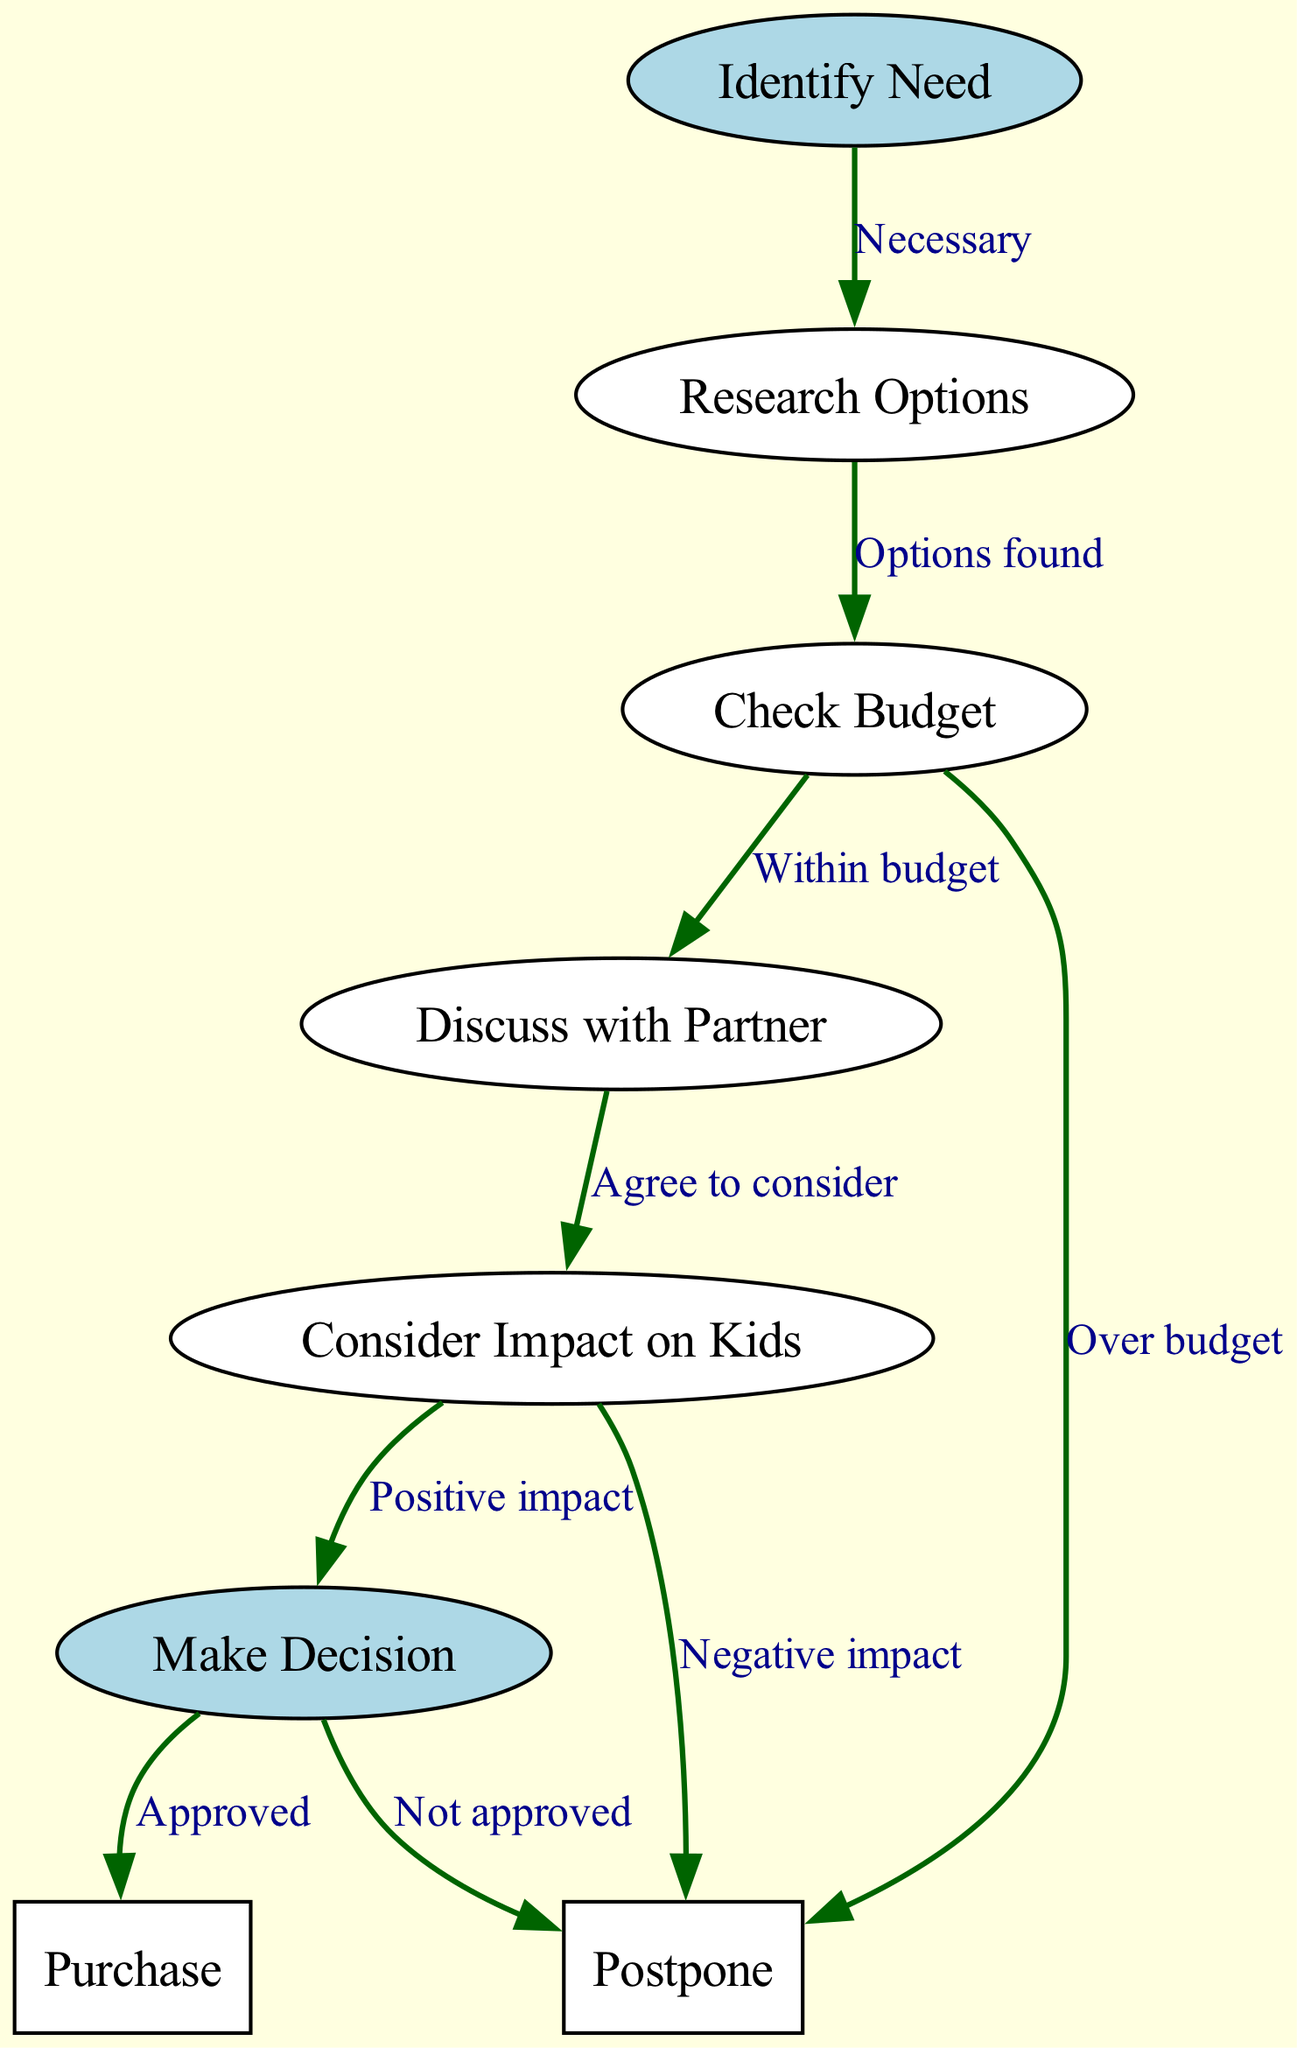What is the first step in the family decision-making process? The first step is "Identify Need", which is clearly labeled as the starting node in the diagram.
Answer: Identify Need How many nodes are there in total? By counting all the nodes listed in the data, we find there are 8 nodes labeled from 1 to 8.
Answer: 8 What must happen after checking the budget if it's within the budget? If the budget is within limits, the next step is to "Discuss with Partner", which follows from the "Check Budget" node.
Answer: Discuss with Partner What does the edge labeled "Over budget" lead to? The edge labeled "Over budget" leads to the "Postpone" node, indicating a situation where spending isn't feasible.
Answer: Postpone What impact do parents consider before making the final decision? Parents consider the impact on kids before making the final decision, as shown in the flow from "Discuss with Partner" to "Consider Impact on Kids".
Answer: Impact on Kids If the decision isn't approved, what is the outcome? If the decision isn't approved, the outcome is to "Postpone", as shown in the flow from "Make Decision" to "Postpone".
Answer: Postpone Which two nodes lead to the same outcome of postponing? The nodes "Over budget" and "Negative impact" both lead to the outcome "Postpone", demonstrating two scenarios that result in delaying the purchase.
Answer: Over budget and Negative impact What type of decisions does this flowchart guide? The flowchart guides "major household purchases", as stated in the context of the diagram.
Answer: Major household purchases 